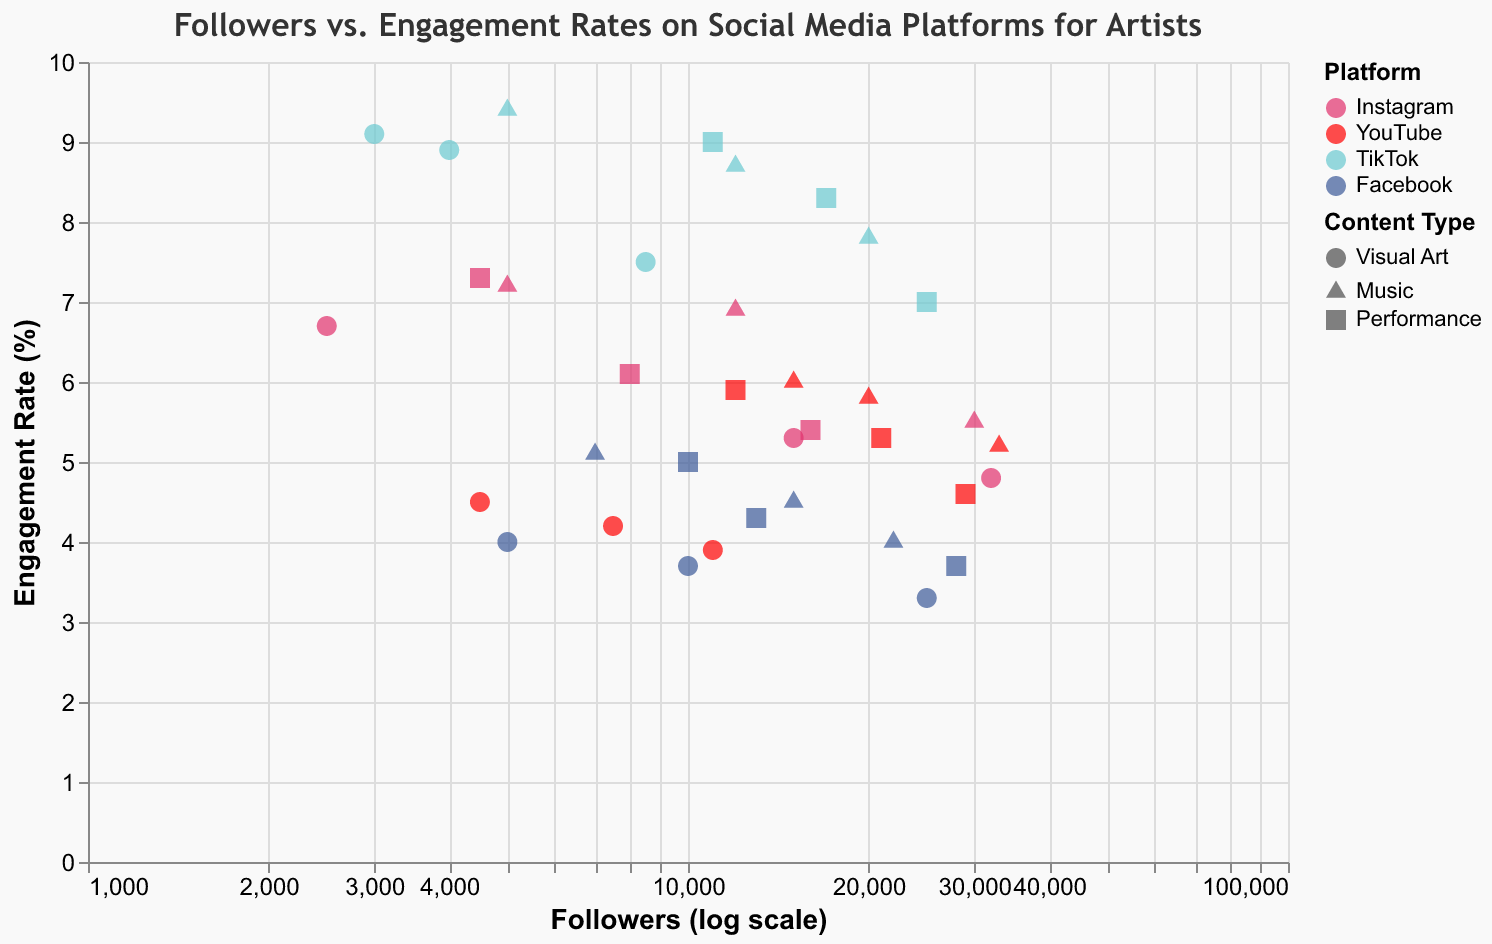How is the engagement rate trend for Visual Art content on TikTok compared to YouTube? First, identify the engagement rates for 'Visual Art' content on TikTok (8.9, 7.5, 9.1) and YouTube (4.5, 3.9, 4.2). Compare the averages for both platforms: TikTok = (8.9 + 7.5 + 9.1) / 3 ≈ 8.5, YouTube = (4.5 + 3.9 + 4.2) / 3 ≈ 4.2. TikTok's engagement rate is significantly higher.
Answer: TikTok has a significantly higher engagement rate Which platform has the highest engagement rate for Music content, and what is it? Check the maximum engagement rates for 'Music' on all platforms: Instagram (7.2), YouTube (6.0), TikTok (9.4), and Facebook (5.1). The highest rate is on TikTok with 9.4%.
Answer: TikTok, 9.4% Between Instagram and Facebook, which platform has a higher median engagement rate for Performance content? List engagement rates for 'Performance' content: Instagram (6.1, 5.4, 7.3) and Facebook (4.3, 3.7, 5.0). Calculate the medians: Instagram median = 6.1, Facebook median = 4.3. Instagram's median engagement rate is higher.
Answer: Instagram For Visual Art content, which social media platform shows the highest variation in engagement rates? Examine 'Visual Art' engagement rates for each platform: Instagram (5.3, 4.8, 6.7), YouTube (4.5, 3.9, 4.2), TikTok (8.9, 7.5, 9.1), Facebook (3.7, 3.3, 4.0). Calculate the standard deviations: TikTok shows the highest variation due to its spread-out values.
Answer: TikTok Do Performance artists on TikTok have a generally higher engagement rate compared to those on Facebook? Compare 'Performance' engagement rates on TikTok (8.3, 7.0, 9.0) with Facebook (4.3, 3.7, 5.0). Average engagement rates are TikTok ≈ 8.1, Facebook ≈ 4.3. TikTok has a higher engagement rate.
Answer: Yes Among the Visual Art content types, which platform shows the lowest average engagement rate? Compare average engagement rates for 'Visual Art': Instagram (5.3), YouTube (4.2), TikTok (8.5), Facebook (3.7). Facebook has the lowest average engagement rate for Visual Art.
Answer: Facebook What is the engagement trend for Music content as the number of followers increases on Instagram? Plot Instagram 'Music' points and observe the trend: engagement decreases as followers increase (7.2 for 5,000 followers, 6.9 for 12,000, 5.5 for 30,000).
Answer: Engagement rate decreases Which platform has the most consistent engagement rate for Performance content across different follower counts? Evaluate 'Performance' content engagement across platforms: Instagram varies (6.1, 5.4, 7.3), YouTube varies moderately (5.3, 4.6, 5.9), TikTok varies (8.3, 7.0, 9.0), Facebook varies (4.3, 3.7, 5.0). YouTube shows relatively consistent values.
Answer: YouTube 